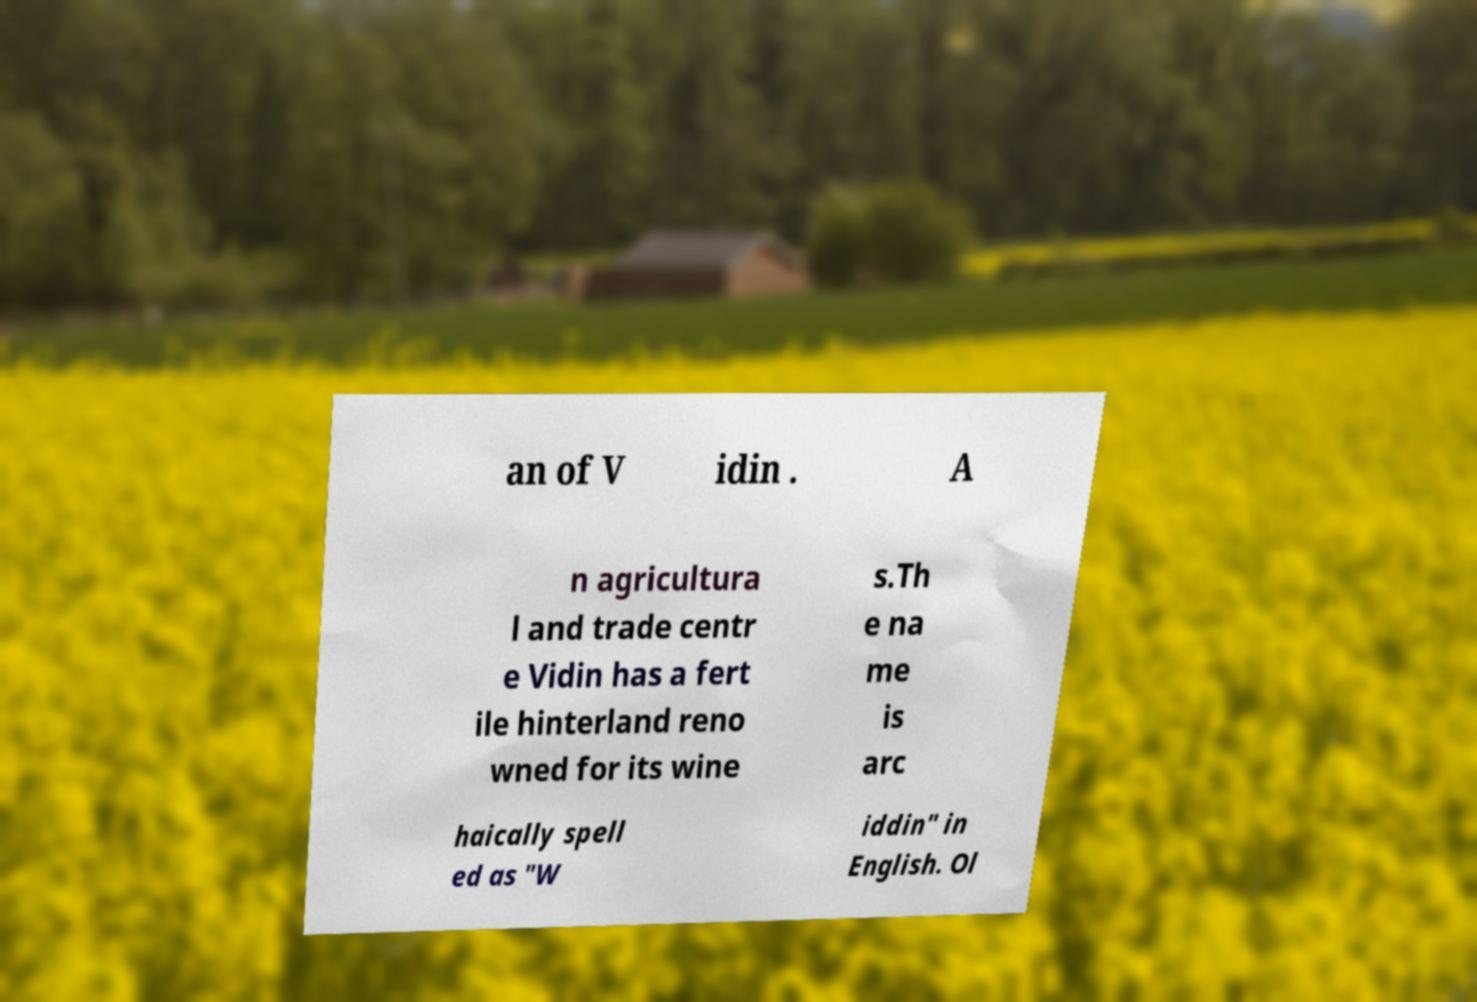What messages or text are displayed in this image? I need them in a readable, typed format. an of V idin . A n agricultura l and trade centr e Vidin has a fert ile hinterland reno wned for its wine s.Th e na me is arc haically spell ed as "W iddin" in English. Ol 